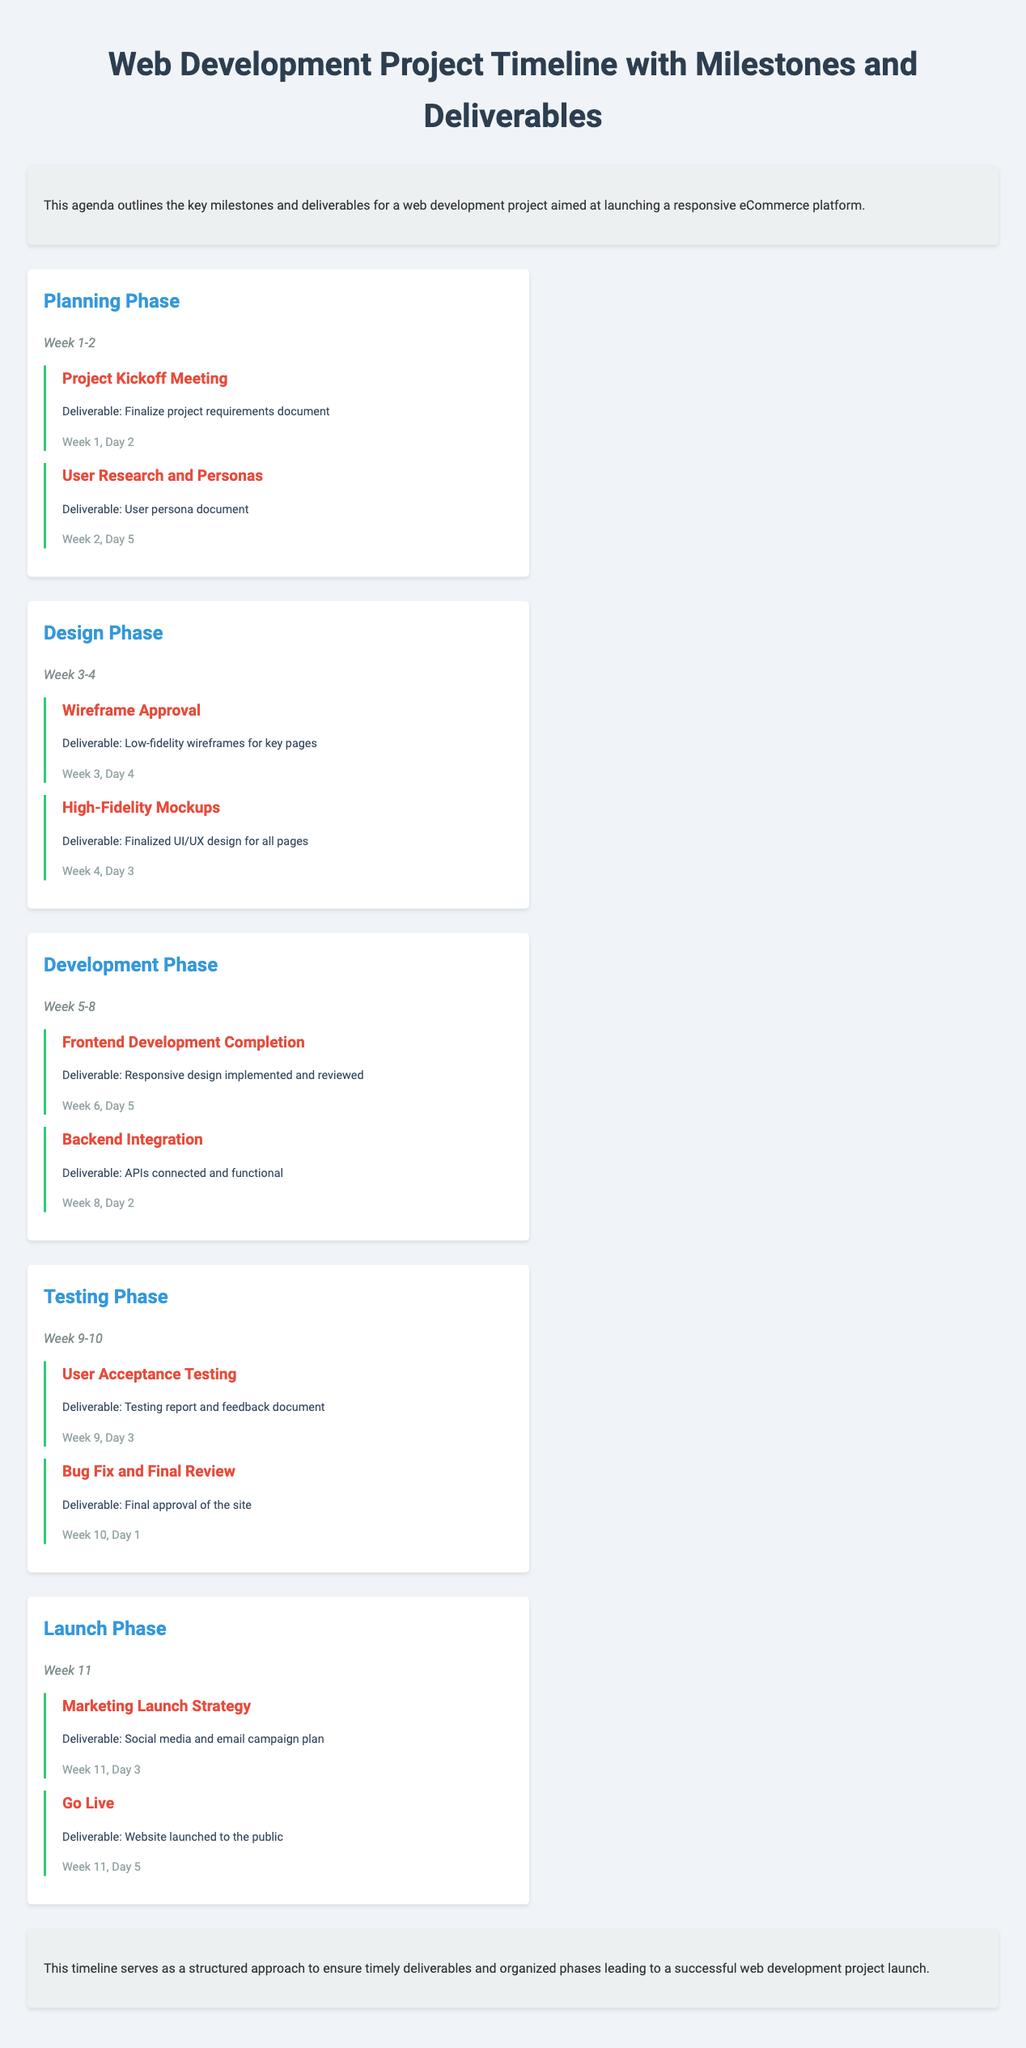What is the duration of the Planning Phase? The Planning Phase lasts from Week 1 to Week 2.
Answer: Week 1-2 When is the User Acceptance Testing milestone scheduled? The User Acceptance Testing milestone is scheduled for Week 9, Day 3.
Answer: Week 9, Day 3 What is the deliverable for Backend Integration? The deliverable for Backend Integration is APIs connected and functional.
Answer: APIs connected and functional How many phases are there in the project timeline? The document outlines five phases in the project timeline.
Answer: Five What is the final deliverable of the project? The final deliverable of the project is the website launched to the public.
Answer: Website launched to the public Which day is designated for the Go Live milestone? The Go Live milestone is set for Week 11, Day 5.
Answer: Week 11, Day 5 What document is created during User Research and Personas? The document created during User Research and Personas is the user persona document.
Answer: User persona document What type of project is this timeline focusing on? The timeline focuses on launching a responsive eCommerce platform.
Answer: Responsive eCommerce platform 